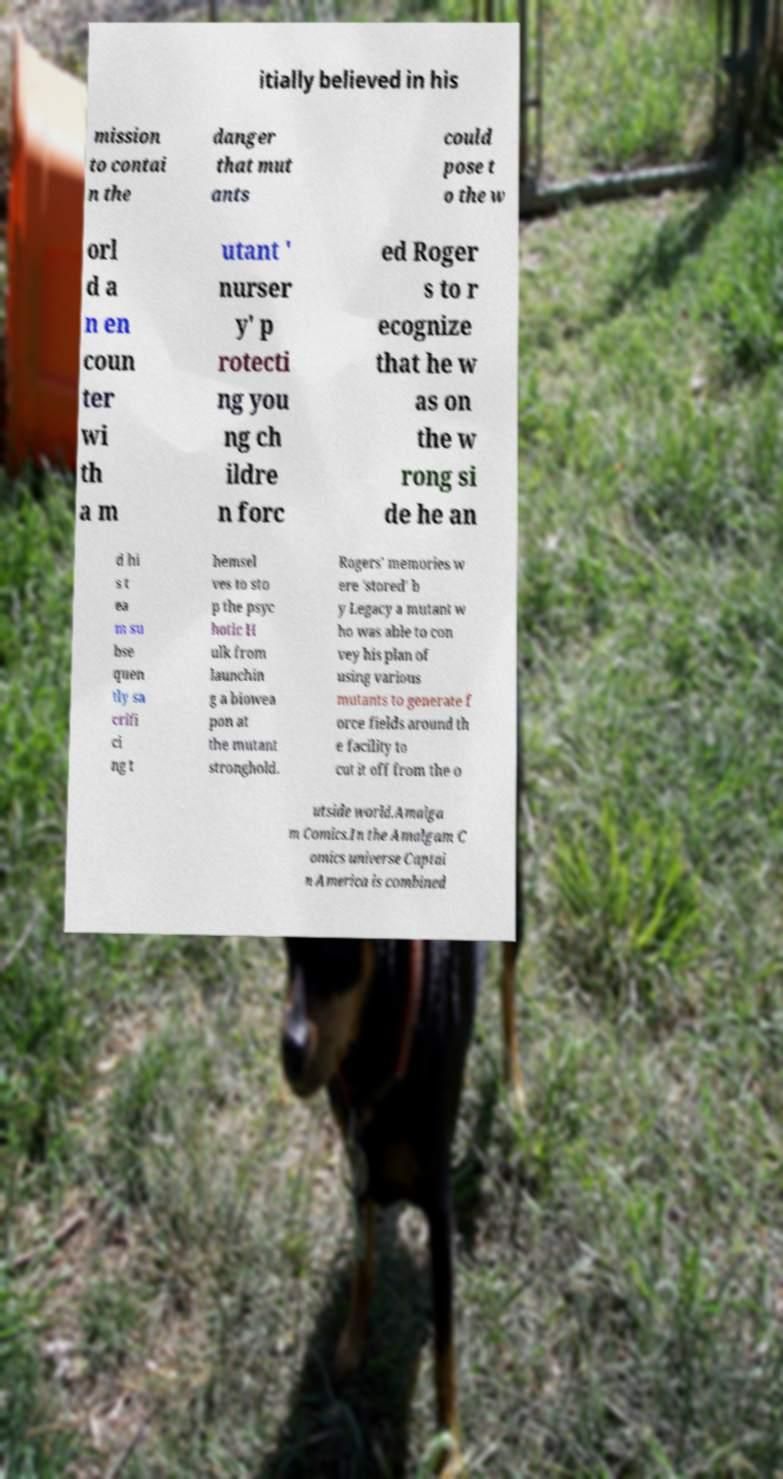Please identify and transcribe the text found in this image. itially believed in his mission to contai n the danger that mut ants could pose t o the w orl d a n en coun ter wi th a m utant ' nurser y' p rotecti ng you ng ch ildre n forc ed Roger s to r ecognize that he w as on the w rong si de he an d hi s t ea m su bse quen tly sa crifi ci ng t hemsel ves to sto p the psyc hotic H ulk from launchin g a biowea pon at the mutant stronghold. Rogers' memories w ere 'stored' b y Legacy a mutant w ho was able to con vey his plan of using various mutants to generate f orce fields around th e facility to cut it off from the o utside world.Amalga m Comics.In the Amalgam C omics universe Captai n America is combined 